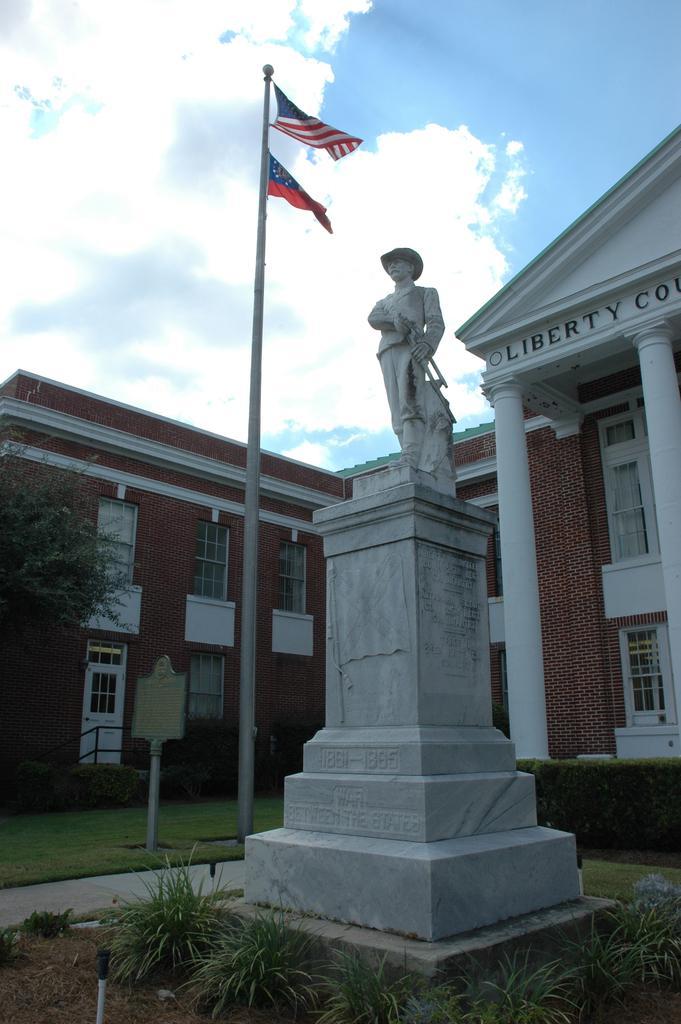How would you summarize this image in a sentence or two? In this picture there is a statue in the center of the image and there are buildings in the background area of the image, there are plants at the bottom side of the image, there is a flag in the center of the image and there is a tree on the left side of the image. 